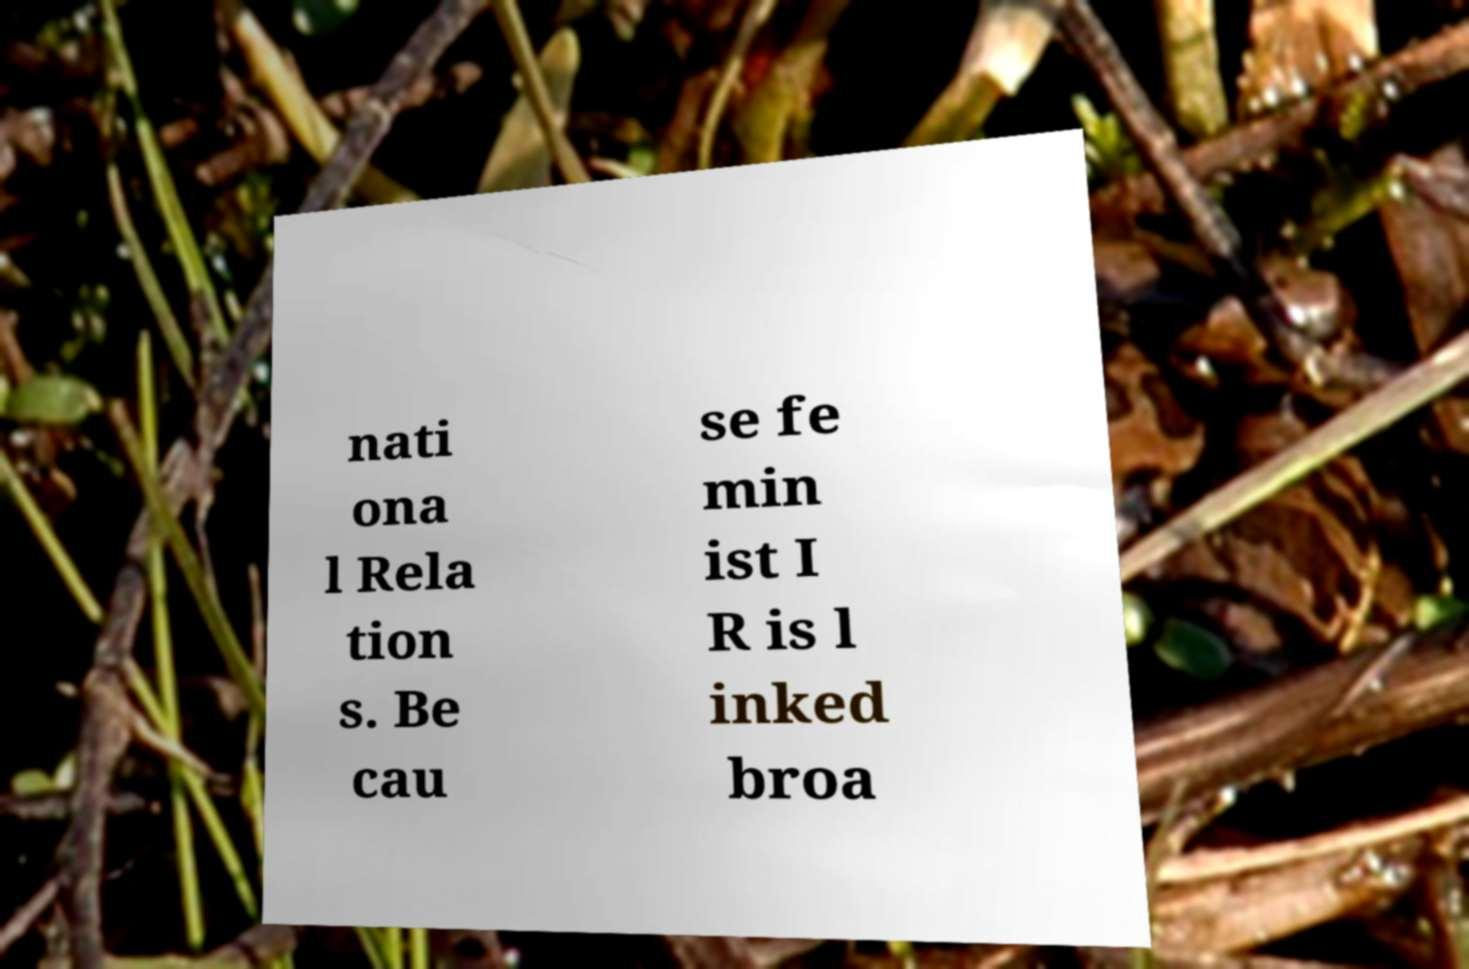I need the written content from this picture converted into text. Can you do that? nati ona l Rela tion s. Be cau se fe min ist I R is l inked broa 